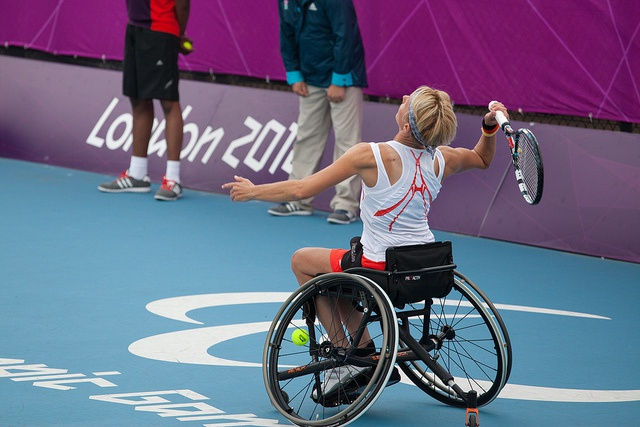Describe the objects in this image and their specific colors. I can see people in purple, black, brown, gray, and lavender tones, people in purple, black, darkgray, gray, and darkblue tones, people in purple, black, gray, maroon, and lightgray tones, tennis racket in purple, gray, black, darkgray, and lightgray tones, and sports ball in purple, lime, olive, and yellow tones in this image. 